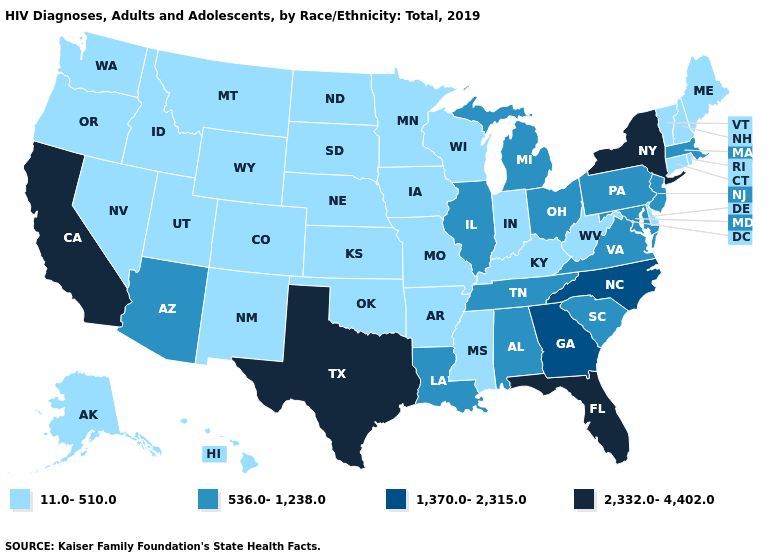Does Pennsylvania have the highest value in the Northeast?
Concise answer only. No. What is the highest value in the West ?
Concise answer only. 2,332.0-4,402.0. What is the value of California?
Short answer required. 2,332.0-4,402.0. What is the highest value in the USA?
Short answer required. 2,332.0-4,402.0. Is the legend a continuous bar?
Answer briefly. No. Name the states that have a value in the range 536.0-1,238.0?
Keep it brief. Alabama, Arizona, Illinois, Louisiana, Maryland, Massachusetts, Michigan, New Jersey, Ohio, Pennsylvania, South Carolina, Tennessee, Virginia. Name the states that have a value in the range 1,370.0-2,315.0?
Quick response, please. Georgia, North Carolina. Name the states that have a value in the range 11.0-510.0?
Short answer required. Alaska, Arkansas, Colorado, Connecticut, Delaware, Hawaii, Idaho, Indiana, Iowa, Kansas, Kentucky, Maine, Minnesota, Mississippi, Missouri, Montana, Nebraska, Nevada, New Hampshire, New Mexico, North Dakota, Oklahoma, Oregon, Rhode Island, South Dakota, Utah, Vermont, Washington, West Virginia, Wisconsin, Wyoming. What is the value of Vermont?
Write a very short answer. 11.0-510.0. Name the states that have a value in the range 536.0-1,238.0?
Short answer required. Alabama, Arizona, Illinois, Louisiana, Maryland, Massachusetts, Michigan, New Jersey, Ohio, Pennsylvania, South Carolina, Tennessee, Virginia. What is the value of Kentucky?
Answer briefly. 11.0-510.0. What is the highest value in the USA?
Quick response, please. 2,332.0-4,402.0. Does Indiana have the highest value in the USA?
Give a very brief answer. No. What is the lowest value in the West?
Be succinct. 11.0-510.0. 